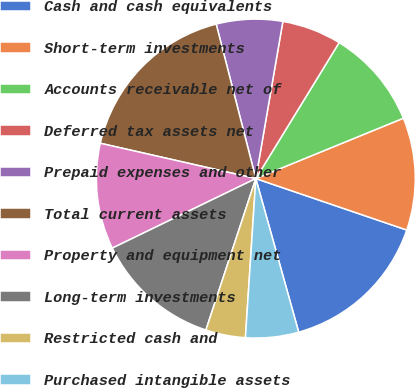<chart> <loc_0><loc_0><loc_500><loc_500><pie_chart><fcel>Cash and cash equivalents<fcel>Short-term investments<fcel>Accounts receivable net of<fcel>Deferred tax assets net<fcel>Prepaid expenses and other<fcel>Total current assets<fcel>Property and equipment net<fcel>Long-term investments<fcel>Restricted cash and<fcel>Purchased intangible assets<nl><fcel>15.44%<fcel>11.41%<fcel>10.07%<fcel>6.04%<fcel>6.71%<fcel>17.45%<fcel>10.74%<fcel>12.75%<fcel>4.03%<fcel>5.37%<nl></chart> 